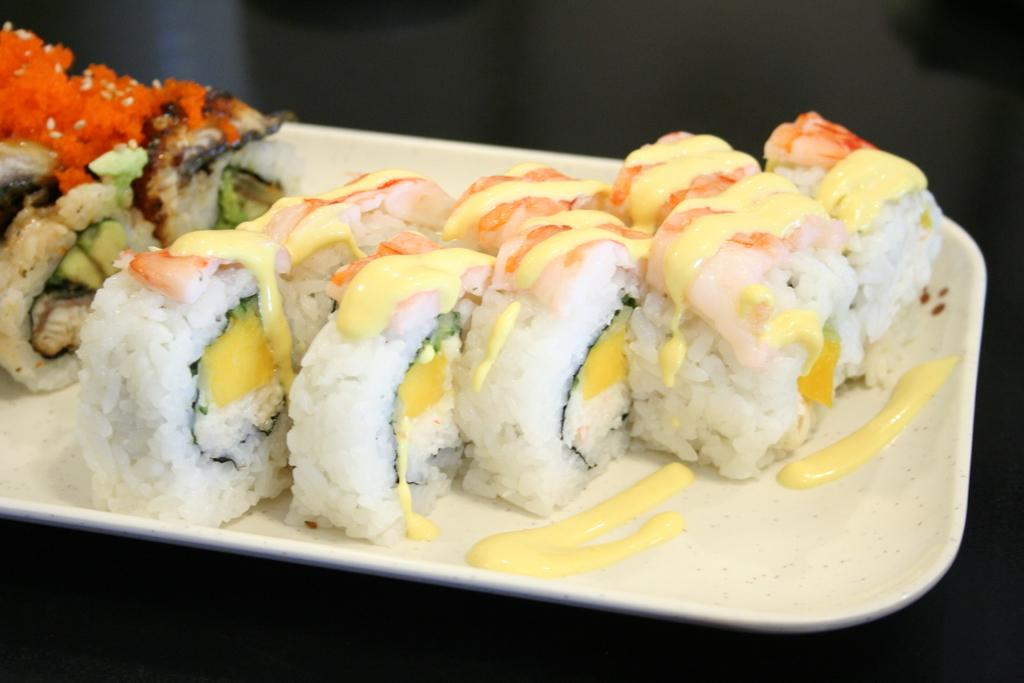What is the main subject of the image? There is a food item in the image. How is the food item presented in the image? The food item is placed on a plate. What color is the wall behind the food item in the image? There is no wall visible in the image; it only shows a food item placed on a plate. 